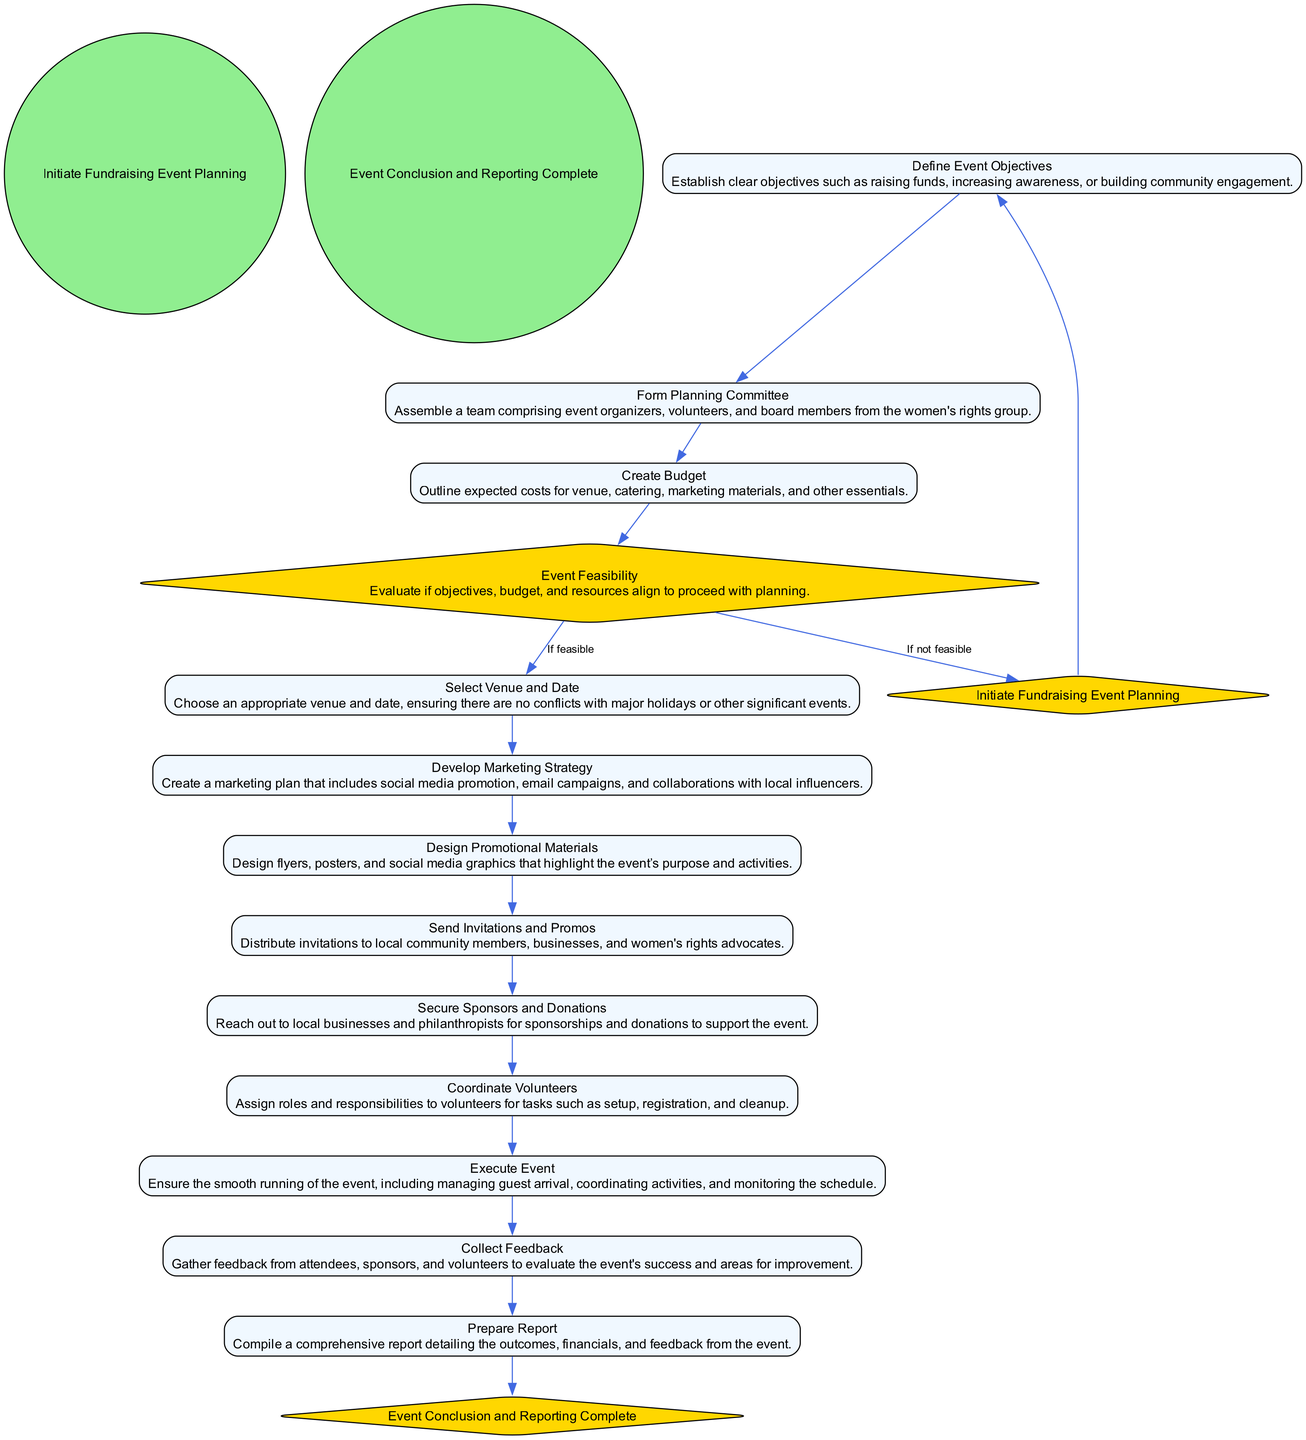What is the starting event in the diagram? The diagram starts with the event labeled "Initiate Fundraising Event Planning" which is specifically indicated as the initial node.
Answer: Initiate Fundraising Event Planning What comes after defining event objectives? According to the diagram, the flow leads from "Define Event Objectives" to "Form Planning Committee" as the next activity.
Answer: Form Planning Committee How many main activities are there before executing the event? By counting the activities listed in the diagram, there are eleven main activities leading up to "Execute Event."
Answer: Eleven What is the condition for proceeding to select venue and date? The flow from "Event Feasibility" to "Select Venue and Date" occurs when the condition "If feasible" is met, indicating that proceeding is dependent on feasibility assessment.
Answer: If feasible Which activity follows the collection of feedback? After "Collect Feedback," the subsequent activity is "Prepare Report," as shown in the flow of the diagram.
Answer: Prepare Report How many decisions are outlined in the diagram? The diagram features one decision node, which is "Event Feasibility," determining if the event can proceed based on assessed criteria.
Answer: One What is the immediate action after securing sponsors and donations? Following "Secure Sponsors and Donations," the next activity is "Coordinate Volunteers," which indicates a sequential flow in event planning.
Answer: Coordinate Volunteers Which event marks the conclusion of the diagram? The end event of the diagram is labeled "Event Conclusion and Reporting Complete," indicating the final node in the process flow.
Answer: Event Conclusion and Reporting Complete What would happen if the event is deemed not feasible? If the event is not feasible, the flow goes back to "Initiate Fundraising Event Planning," suggesting that planning would restart rather than move forward.
Answer: Initiate Fundraising Event Planning 